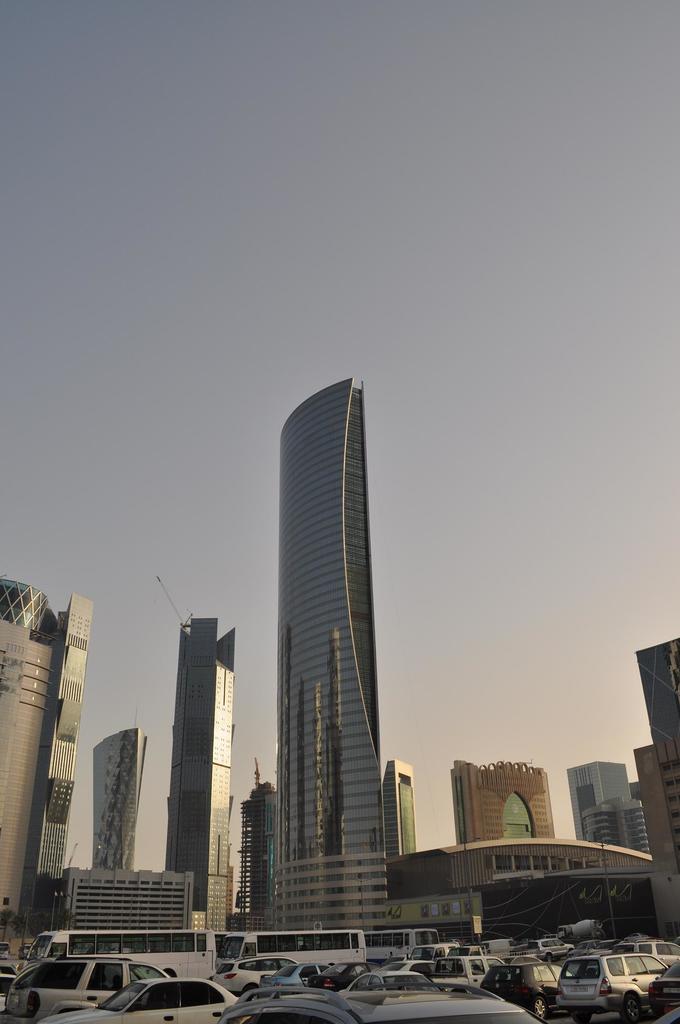Describe this image in one or two sentences. In this picture I can observe buildings. In the bottom of the picture I can observe vehicles on the road. In the background I can observe sky. 